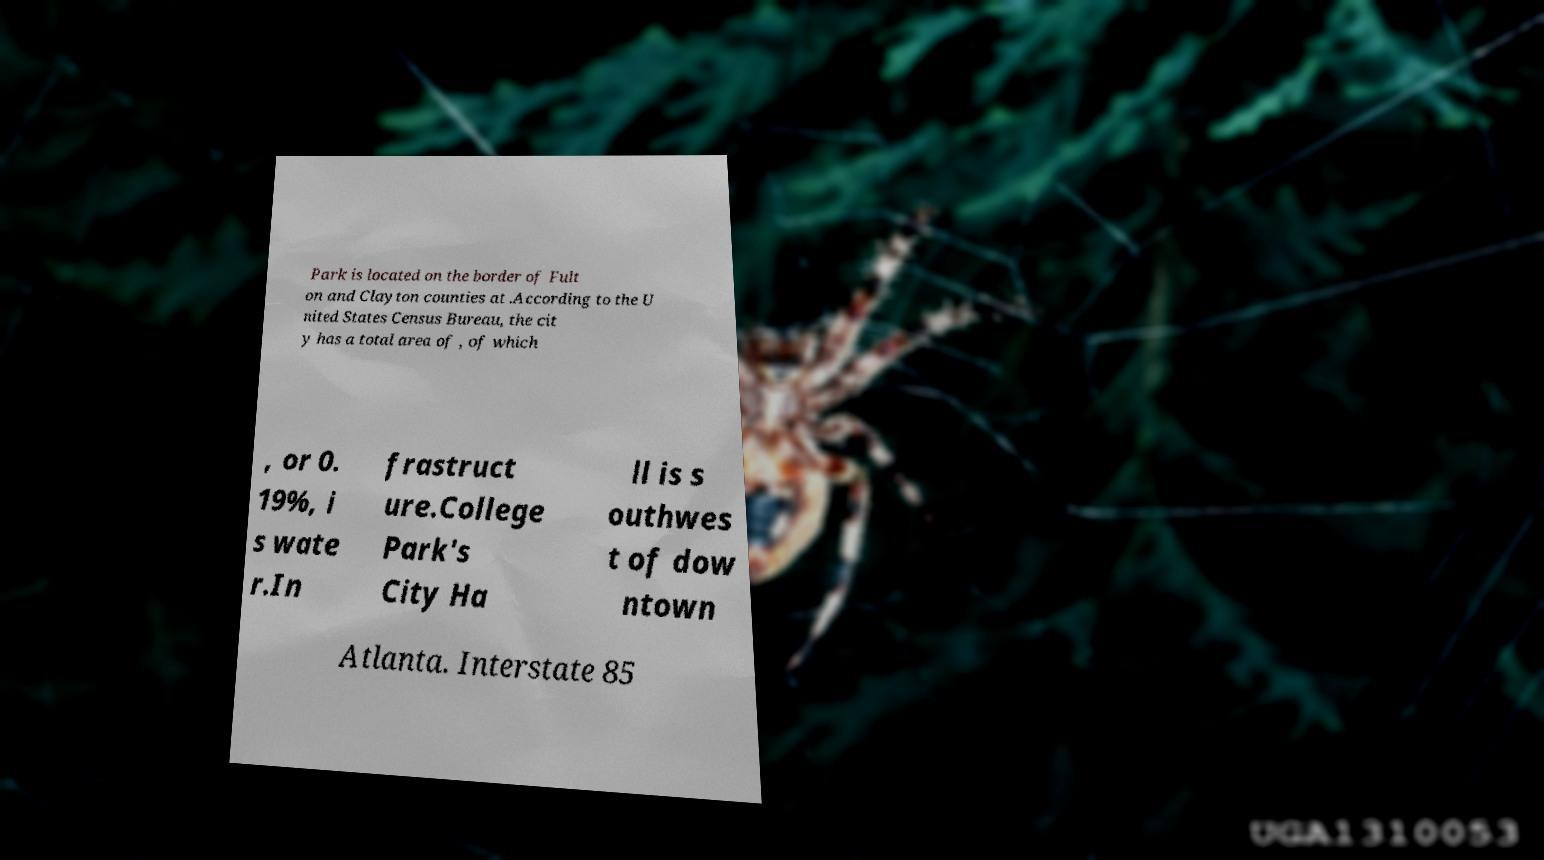For documentation purposes, I need the text within this image transcribed. Could you provide that? Park is located on the border of Fult on and Clayton counties at .According to the U nited States Census Bureau, the cit y has a total area of , of which , or 0. 19%, i s wate r.In frastruct ure.College Park's City Ha ll is s outhwes t of dow ntown Atlanta. Interstate 85 